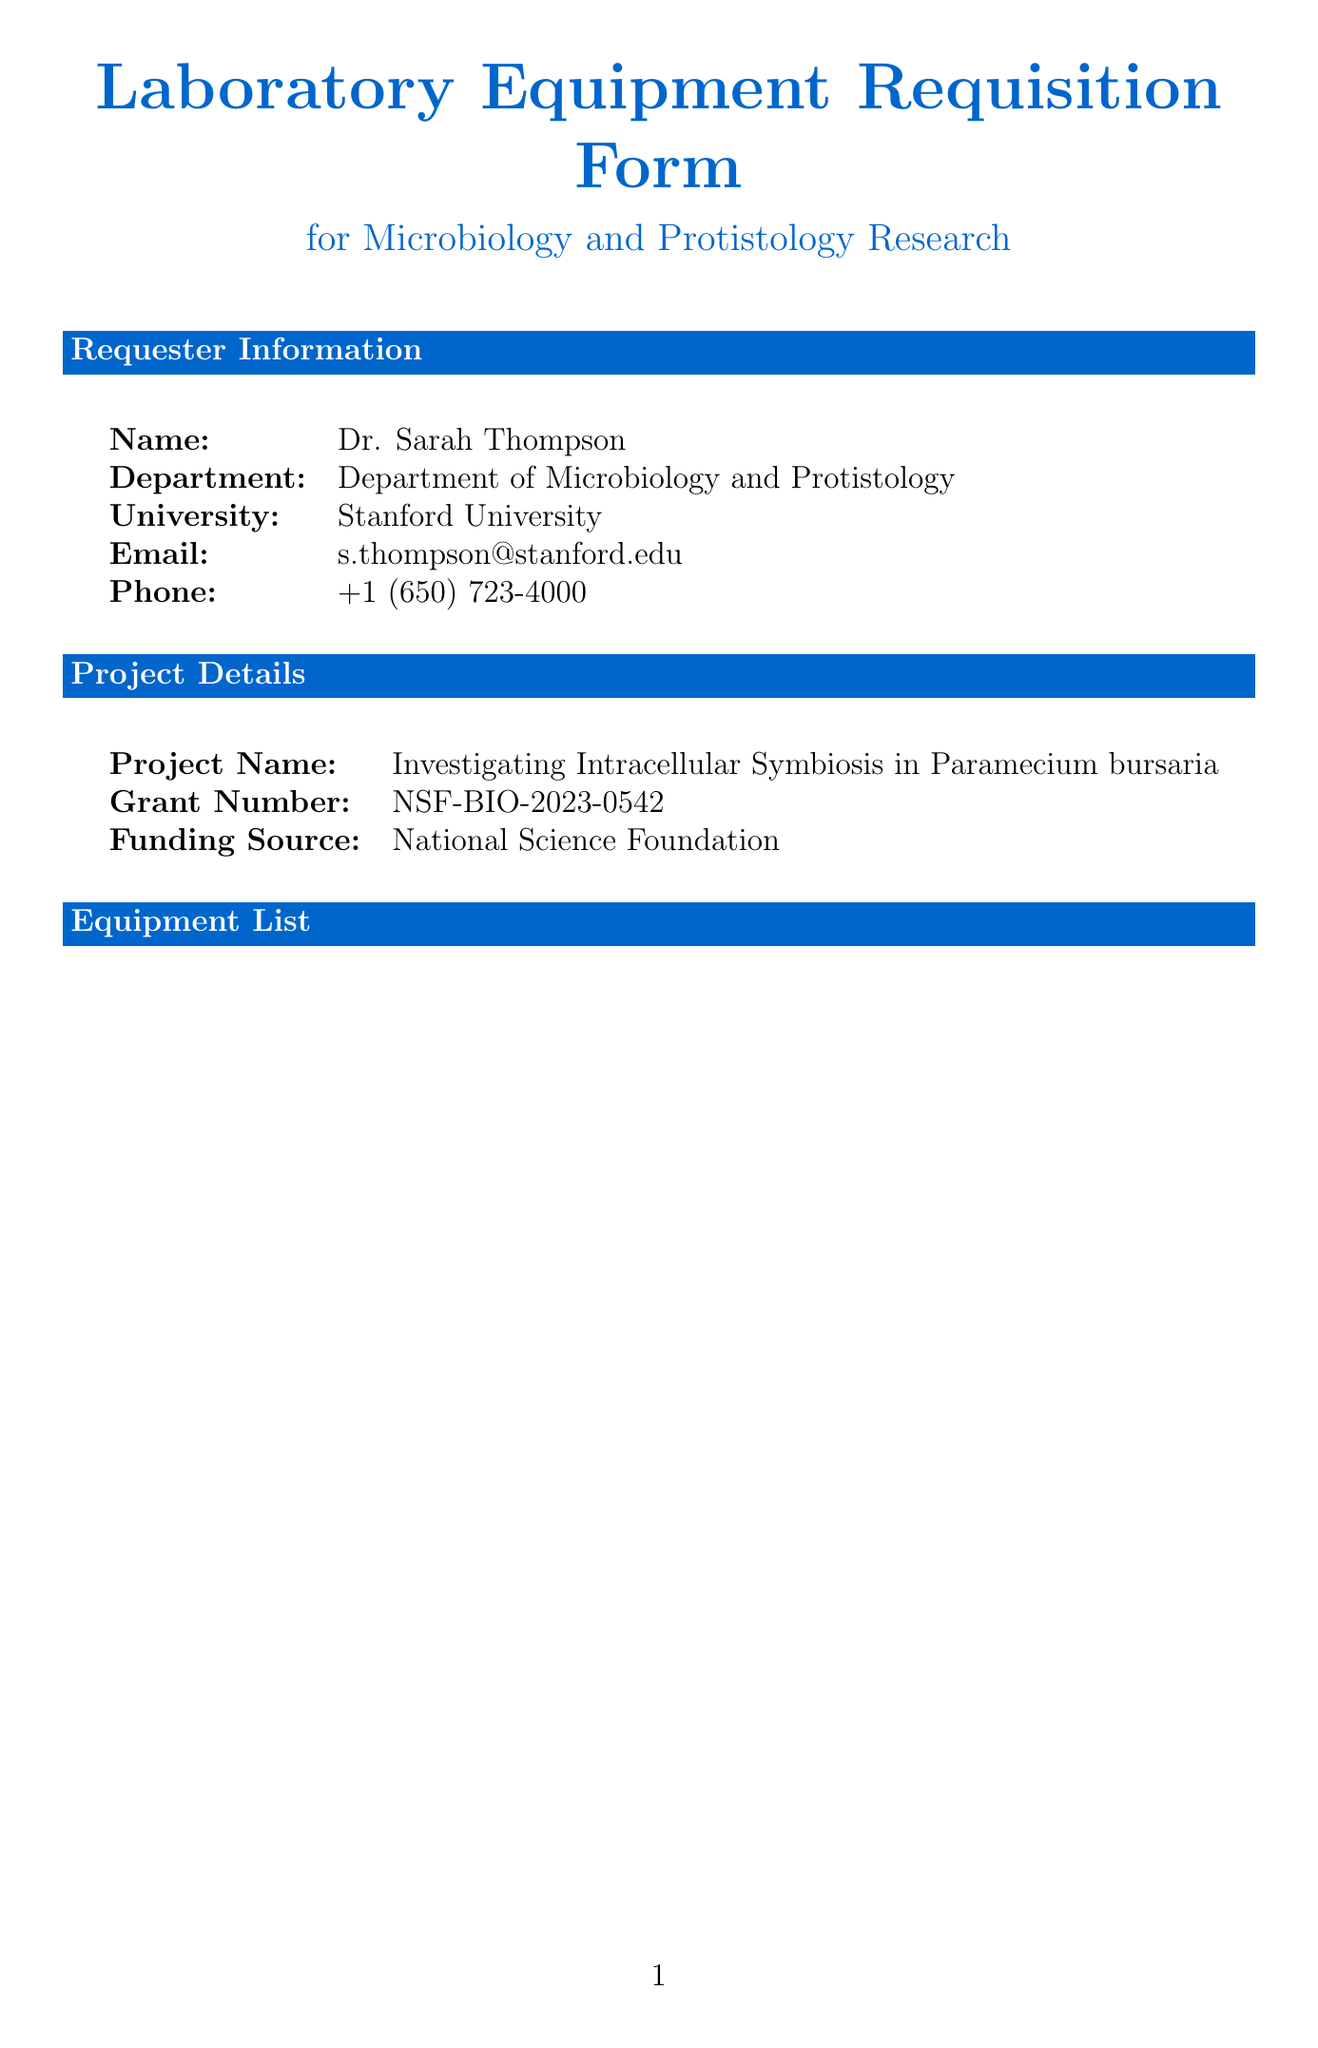What is the name of the requester? The name of the requester is present in the requester information section of the document.
Answer: Dr. Sarah Thompson What is the estimated cost of the Leica DMi8 Inverted Microscope? The estimated cost can be found in the equipment list section next to the item name.
Answer: 75000 How many Olympus CX43 Binocular Microscopes are requested? The quantity requested is specified in the equipment list next to the item name.
Answer: 5 What is the total budget allocated for this requisition? The total budget is provided in the budget allocation section of the document.
Answer: 200000 What is the justification for the BioTek Synergy H1 Microplate Reader? The justification is included in the equipment list next to the estimated cost for that item.
Answer: Quantitative analysis of protist growth and metabolic activities What is the remaining budget after equipment costs? The remaining budget is calculated from the total budget minus the equipment subtotal, provided in the budget allocation section.
Answer: 48000 Who is the Dean of Research? The Dean of Research's name is listed in the approval section of the document.
Answer: Dr. Emily Rodriguez What are the additional costs mentioned in the budget allocation? The additional costs are listed in an itemized format under the budget allocation section.
Answer: Installation and setup, service contracts, consumables and reagents What is the project name associated with the requisition? The project name is mentioned in the project details section of the document.
Answer: Investigating Intracellular Symbiosis in Paramecium bursaria 